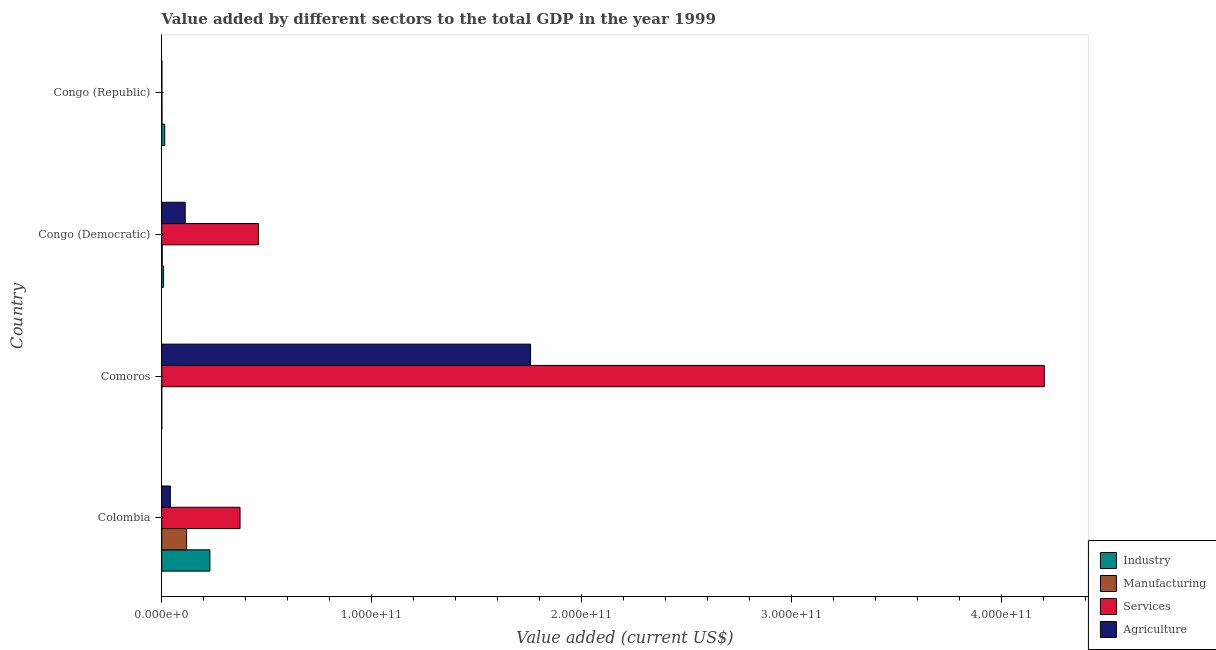How many groups of bars are there?
Offer a terse response. 4. How many bars are there on the 1st tick from the top?
Your answer should be very brief. 4. What is the label of the 1st group of bars from the top?
Your answer should be very brief. Congo (Republic). In how many cases, is the number of bars for a given country not equal to the number of legend labels?
Keep it short and to the point. 0. What is the value added by manufacturing sector in Congo (Democratic)?
Provide a succinct answer. 2.36e+08. Across all countries, what is the maximum value added by industrial sector?
Make the answer very short. 2.30e+1. Across all countries, what is the minimum value added by services sector?
Give a very brief answer. 1.05e+08. In which country was the value added by agricultural sector maximum?
Your answer should be compact. Comoros. In which country was the value added by services sector minimum?
Your answer should be very brief. Congo (Republic). What is the total value added by agricultural sector in the graph?
Provide a short and direct response. 1.91e+11. What is the difference between the value added by manufacturing sector in Colombia and that in Comoros?
Your answer should be very brief. 1.19e+1. What is the difference between the value added by services sector in Colombia and the value added by agricultural sector in Comoros?
Provide a short and direct response. -1.38e+11. What is the average value added by industrial sector per country?
Provide a succinct answer. 6.33e+09. What is the difference between the value added by services sector and value added by industrial sector in Congo (Democratic)?
Your answer should be compact. 4.52e+1. In how many countries, is the value added by manufacturing sector greater than 140000000000 US$?
Your response must be concise. 0. What is the ratio of the value added by services sector in Comoros to that in Congo (Republic)?
Your response must be concise. 4010.61. Is the difference between the value added by manufacturing sector in Colombia and Congo (Democratic) greater than the difference between the value added by agricultural sector in Colombia and Congo (Democratic)?
Provide a succinct answer. Yes. What is the difference between the highest and the second highest value added by manufacturing sector?
Your answer should be compact. 1.16e+1. What is the difference between the highest and the lowest value added by industrial sector?
Make the answer very short. 2.29e+1. Is the sum of the value added by services sector in Comoros and Congo (Democratic) greater than the maximum value added by industrial sector across all countries?
Your answer should be very brief. Yes. Is it the case that in every country, the sum of the value added by agricultural sector and value added by services sector is greater than the sum of value added by manufacturing sector and value added by industrial sector?
Ensure brevity in your answer.  No. What does the 4th bar from the top in Congo (Democratic) represents?
Your answer should be compact. Industry. What does the 4th bar from the bottom in Comoros represents?
Your answer should be very brief. Agriculture. What is the difference between two consecutive major ticks on the X-axis?
Offer a terse response. 1.00e+11. Are the values on the major ticks of X-axis written in scientific E-notation?
Offer a very short reply. Yes. Does the graph contain any zero values?
Your response must be concise. No. Does the graph contain grids?
Keep it short and to the point. No. Where does the legend appear in the graph?
Provide a short and direct response. Bottom right. How are the legend labels stacked?
Give a very brief answer. Vertical. What is the title of the graph?
Your answer should be very brief. Value added by different sectors to the total GDP in the year 1999. What is the label or title of the X-axis?
Give a very brief answer. Value added (current US$). What is the Value added (current US$) of Industry in Colombia?
Your answer should be very brief. 2.30e+1. What is the Value added (current US$) of Manufacturing in Colombia?
Offer a very short reply. 1.19e+1. What is the Value added (current US$) in Services in Colombia?
Give a very brief answer. 3.73e+1. What is the Value added (current US$) of Agriculture in Colombia?
Keep it short and to the point. 4.10e+09. What is the Value added (current US$) in Industry in Comoros?
Your response must be concise. 2.66e+07. What is the Value added (current US$) of Manufacturing in Comoros?
Provide a succinct answer. 9.27e+06. What is the Value added (current US$) of Services in Comoros?
Your response must be concise. 4.21e+11. What is the Value added (current US$) of Agriculture in Comoros?
Your answer should be very brief. 1.76e+11. What is the Value added (current US$) in Industry in Congo (Democratic)?
Your answer should be very brief. 8.82e+08. What is the Value added (current US$) in Manufacturing in Congo (Democratic)?
Your response must be concise. 2.36e+08. What is the Value added (current US$) of Services in Congo (Democratic)?
Your answer should be very brief. 4.61e+1. What is the Value added (current US$) of Agriculture in Congo (Democratic)?
Offer a terse response. 1.12e+1. What is the Value added (current US$) of Industry in Congo (Republic)?
Make the answer very short. 1.44e+09. What is the Value added (current US$) in Manufacturing in Congo (Republic)?
Keep it short and to the point. 1.29e+08. What is the Value added (current US$) of Services in Congo (Republic)?
Provide a short and direct response. 1.05e+08. What is the Value added (current US$) of Agriculture in Congo (Republic)?
Make the answer very short. 9.11e+07. Across all countries, what is the maximum Value added (current US$) of Industry?
Offer a terse response. 2.30e+1. Across all countries, what is the maximum Value added (current US$) of Manufacturing?
Provide a succinct answer. 1.19e+1. Across all countries, what is the maximum Value added (current US$) in Services?
Offer a very short reply. 4.21e+11. Across all countries, what is the maximum Value added (current US$) in Agriculture?
Provide a short and direct response. 1.76e+11. Across all countries, what is the minimum Value added (current US$) of Industry?
Your response must be concise. 2.66e+07. Across all countries, what is the minimum Value added (current US$) in Manufacturing?
Give a very brief answer. 9.27e+06. Across all countries, what is the minimum Value added (current US$) of Services?
Offer a terse response. 1.05e+08. Across all countries, what is the minimum Value added (current US$) in Agriculture?
Make the answer very short. 9.11e+07. What is the total Value added (current US$) of Industry in the graph?
Keep it short and to the point. 2.53e+1. What is the total Value added (current US$) of Manufacturing in the graph?
Offer a terse response. 1.22e+1. What is the total Value added (current US$) in Services in the graph?
Provide a short and direct response. 5.04e+11. What is the total Value added (current US$) in Agriculture in the graph?
Give a very brief answer. 1.91e+11. What is the difference between the Value added (current US$) of Industry in Colombia and that in Comoros?
Your answer should be compact. 2.29e+1. What is the difference between the Value added (current US$) in Manufacturing in Colombia and that in Comoros?
Provide a succinct answer. 1.19e+1. What is the difference between the Value added (current US$) in Services in Colombia and that in Comoros?
Your answer should be very brief. -3.83e+11. What is the difference between the Value added (current US$) of Agriculture in Colombia and that in Comoros?
Your answer should be very brief. -1.72e+11. What is the difference between the Value added (current US$) in Industry in Colombia and that in Congo (Democratic)?
Your response must be concise. 2.21e+1. What is the difference between the Value added (current US$) in Manufacturing in Colombia and that in Congo (Democratic)?
Provide a succinct answer. 1.16e+1. What is the difference between the Value added (current US$) of Services in Colombia and that in Congo (Democratic)?
Provide a short and direct response. -8.77e+09. What is the difference between the Value added (current US$) of Agriculture in Colombia and that in Congo (Democratic)?
Offer a very short reply. -7.10e+09. What is the difference between the Value added (current US$) in Industry in Colombia and that in Congo (Republic)?
Keep it short and to the point. 2.15e+1. What is the difference between the Value added (current US$) of Manufacturing in Colombia and that in Congo (Republic)?
Your answer should be compact. 1.17e+1. What is the difference between the Value added (current US$) in Services in Colombia and that in Congo (Republic)?
Provide a short and direct response. 3.72e+1. What is the difference between the Value added (current US$) in Agriculture in Colombia and that in Congo (Republic)?
Provide a short and direct response. 4.01e+09. What is the difference between the Value added (current US$) of Industry in Comoros and that in Congo (Democratic)?
Offer a terse response. -8.55e+08. What is the difference between the Value added (current US$) in Manufacturing in Comoros and that in Congo (Democratic)?
Your answer should be compact. -2.27e+08. What is the difference between the Value added (current US$) in Services in Comoros and that in Congo (Democratic)?
Offer a very short reply. 3.74e+11. What is the difference between the Value added (current US$) of Agriculture in Comoros and that in Congo (Democratic)?
Your answer should be compact. 1.65e+11. What is the difference between the Value added (current US$) of Industry in Comoros and that in Congo (Republic)?
Your answer should be very brief. -1.42e+09. What is the difference between the Value added (current US$) in Manufacturing in Comoros and that in Congo (Republic)?
Give a very brief answer. -1.19e+08. What is the difference between the Value added (current US$) in Services in Comoros and that in Congo (Republic)?
Your response must be concise. 4.20e+11. What is the difference between the Value added (current US$) of Agriculture in Comoros and that in Congo (Republic)?
Your response must be concise. 1.76e+11. What is the difference between the Value added (current US$) of Industry in Congo (Democratic) and that in Congo (Republic)?
Make the answer very short. -5.61e+08. What is the difference between the Value added (current US$) of Manufacturing in Congo (Democratic) and that in Congo (Republic)?
Provide a short and direct response. 1.08e+08. What is the difference between the Value added (current US$) in Services in Congo (Democratic) and that in Congo (Republic)?
Offer a terse response. 4.60e+1. What is the difference between the Value added (current US$) in Agriculture in Congo (Democratic) and that in Congo (Republic)?
Your response must be concise. 1.11e+1. What is the difference between the Value added (current US$) in Industry in Colombia and the Value added (current US$) in Manufacturing in Comoros?
Your response must be concise. 2.29e+1. What is the difference between the Value added (current US$) in Industry in Colombia and the Value added (current US$) in Services in Comoros?
Ensure brevity in your answer.  -3.98e+11. What is the difference between the Value added (current US$) of Industry in Colombia and the Value added (current US$) of Agriculture in Comoros?
Keep it short and to the point. -1.53e+11. What is the difference between the Value added (current US$) of Manufacturing in Colombia and the Value added (current US$) of Services in Comoros?
Offer a terse response. -4.09e+11. What is the difference between the Value added (current US$) of Manufacturing in Colombia and the Value added (current US$) of Agriculture in Comoros?
Make the answer very short. -1.64e+11. What is the difference between the Value added (current US$) of Services in Colombia and the Value added (current US$) of Agriculture in Comoros?
Your response must be concise. -1.38e+11. What is the difference between the Value added (current US$) in Industry in Colombia and the Value added (current US$) in Manufacturing in Congo (Democratic)?
Provide a succinct answer. 2.27e+1. What is the difference between the Value added (current US$) of Industry in Colombia and the Value added (current US$) of Services in Congo (Democratic)?
Ensure brevity in your answer.  -2.31e+1. What is the difference between the Value added (current US$) in Industry in Colombia and the Value added (current US$) in Agriculture in Congo (Democratic)?
Provide a short and direct response. 1.17e+1. What is the difference between the Value added (current US$) in Manufacturing in Colombia and the Value added (current US$) in Services in Congo (Democratic)?
Make the answer very short. -3.42e+1. What is the difference between the Value added (current US$) in Manufacturing in Colombia and the Value added (current US$) in Agriculture in Congo (Democratic)?
Give a very brief answer. 6.56e+08. What is the difference between the Value added (current US$) in Services in Colombia and the Value added (current US$) in Agriculture in Congo (Democratic)?
Give a very brief answer. 2.61e+1. What is the difference between the Value added (current US$) in Industry in Colombia and the Value added (current US$) in Manufacturing in Congo (Republic)?
Your response must be concise. 2.28e+1. What is the difference between the Value added (current US$) of Industry in Colombia and the Value added (current US$) of Services in Congo (Republic)?
Provide a short and direct response. 2.28e+1. What is the difference between the Value added (current US$) of Industry in Colombia and the Value added (current US$) of Agriculture in Congo (Republic)?
Ensure brevity in your answer.  2.29e+1. What is the difference between the Value added (current US$) in Manufacturing in Colombia and the Value added (current US$) in Services in Congo (Republic)?
Make the answer very short. 1.18e+1. What is the difference between the Value added (current US$) of Manufacturing in Colombia and the Value added (current US$) of Agriculture in Congo (Republic)?
Give a very brief answer. 1.18e+1. What is the difference between the Value added (current US$) of Services in Colombia and the Value added (current US$) of Agriculture in Congo (Republic)?
Provide a short and direct response. 3.72e+1. What is the difference between the Value added (current US$) of Industry in Comoros and the Value added (current US$) of Manufacturing in Congo (Democratic)?
Your answer should be very brief. -2.10e+08. What is the difference between the Value added (current US$) in Industry in Comoros and the Value added (current US$) in Services in Congo (Democratic)?
Your response must be concise. -4.61e+1. What is the difference between the Value added (current US$) of Industry in Comoros and the Value added (current US$) of Agriculture in Congo (Democratic)?
Offer a terse response. -1.12e+1. What is the difference between the Value added (current US$) of Manufacturing in Comoros and the Value added (current US$) of Services in Congo (Democratic)?
Offer a very short reply. -4.61e+1. What is the difference between the Value added (current US$) in Manufacturing in Comoros and the Value added (current US$) in Agriculture in Congo (Democratic)?
Offer a very short reply. -1.12e+1. What is the difference between the Value added (current US$) of Services in Comoros and the Value added (current US$) of Agriculture in Congo (Democratic)?
Your answer should be compact. 4.09e+11. What is the difference between the Value added (current US$) in Industry in Comoros and the Value added (current US$) in Manufacturing in Congo (Republic)?
Keep it short and to the point. -1.02e+08. What is the difference between the Value added (current US$) in Industry in Comoros and the Value added (current US$) in Services in Congo (Republic)?
Give a very brief answer. -7.83e+07. What is the difference between the Value added (current US$) of Industry in Comoros and the Value added (current US$) of Agriculture in Congo (Republic)?
Make the answer very short. -6.46e+07. What is the difference between the Value added (current US$) of Manufacturing in Comoros and the Value added (current US$) of Services in Congo (Republic)?
Make the answer very short. -9.56e+07. What is the difference between the Value added (current US$) in Manufacturing in Comoros and the Value added (current US$) in Agriculture in Congo (Republic)?
Your answer should be very brief. -8.19e+07. What is the difference between the Value added (current US$) in Services in Comoros and the Value added (current US$) in Agriculture in Congo (Republic)?
Your answer should be compact. 4.20e+11. What is the difference between the Value added (current US$) in Industry in Congo (Democratic) and the Value added (current US$) in Manufacturing in Congo (Republic)?
Provide a short and direct response. 7.53e+08. What is the difference between the Value added (current US$) of Industry in Congo (Democratic) and the Value added (current US$) of Services in Congo (Republic)?
Ensure brevity in your answer.  7.77e+08. What is the difference between the Value added (current US$) of Industry in Congo (Democratic) and the Value added (current US$) of Agriculture in Congo (Republic)?
Provide a succinct answer. 7.91e+08. What is the difference between the Value added (current US$) of Manufacturing in Congo (Democratic) and the Value added (current US$) of Services in Congo (Republic)?
Provide a short and direct response. 1.31e+08. What is the difference between the Value added (current US$) of Manufacturing in Congo (Democratic) and the Value added (current US$) of Agriculture in Congo (Republic)?
Your response must be concise. 1.45e+08. What is the difference between the Value added (current US$) of Services in Congo (Democratic) and the Value added (current US$) of Agriculture in Congo (Republic)?
Provide a succinct answer. 4.60e+1. What is the average Value added (current US$) in Industry per country?
Ensure brevity in your answer.  6.33e+09. What is the average Value added (current US$) in Manufacturing per country?
Offer a terse response. 3.06e+09. What is the average Value added (current US$) of Services per country?
Your answer should be compact. 1.26e+11. What is the average Value added (current US$) of Agriculture per country?
Ensure brevity in your answer.  4.78e+1. What is the difference between the Value added (current US$) of Industry and Value added (current US$) of Manufacturing in Colombia?
Provide a succinct answer. 1.11e+1. What is the difference between the Value added (current US$) of Industry and Value added (current US$) of Services in Colombia?
Provide a short and direct response. -1.44e+1. What is the difference between the Value added (current US$) in Industry and Value added (current US$) in Agriculture in Colombia?
Ensure brevity in your answer.  1.89e+1. What is the difference between the Value added (current US$) of Manufacturing and Value added (current US$) of Services in Colombia?
Offer a terse response. -2.55e+1. What is the difference between the Value added (current US$) of Manufacturing and Value added (current US$) of Agriculture in Colombia?
Give a very brief answer. 7.76e+09. What is the difference between the Value added (current US$) in Services and Value added (current US$) in Agriculture in Colombia?
Your answer should be very brief. 3.32e+1. What is the difference between the Value added (current US$) of Industry and Value added (current US$) of Manufacturing in Comoros?
Your response must be concise. 1.73e+07. What is the difference between the Value added (current US$) of Industry and Value added (current US$) of Services in Comoros?
Offer a terse response. -4.20e+11. What is the difference between the Value added (current US$) in Industry and Value added (current US$) in Agriculture in Comoros?
Your response must be concise. -1.76e+11. What is the difference between the Value added (current US$) of Manufacturing and Value added (current US$) of Services in Comoros?
Offer a terse response. -4.21e+11. What is the difference between the Value added (current US$) of Manufacturing and Value added (current US$) of Agriculture in Comoros?
Ensure brevity in your answer.  -1.76e+11. What is the difference between the Value added (current US$) of Services and Value added (current US$) of Agriculture in Comoros?
Offer a terse response. 2.45e+11. What is the difference between the Value added (current US$) in Industry and Value added (current US$) in Manufacturing in Congo (Democratic)?
Keep it short and to the point. 6.45e+08. What is the difference between the Value added (current US$) of Industry and Value added (current US$) of Services in Congo (Democratic)?
Give a very brief answer. -4.52e+1. What is the difference between the Value added (current US$) of Industry and Value added (current US$) of Agriculture in Congo (Democratic)?
Your response must be concise. -1.03e+1. What is the difference between the Value added (current US$) of Manufacturing and Value added (current US$) of Services in Congo (Democratic)?
Provide a short and direct response. -4.59e+1. What is the difference between the Value added (current US$) of Manufacturing and Value added (current US$) of Agriculture in Congo (Democratic)?
Make the answer very short. -1.10e+1. What is the difference between the Value added (current US$) in Services and Value added (current US$) in Agriculture in Congo (Democratic)?
Your answer should be very brief. 3.49e+1. What is the difference between the Value added (current US$) in Industry and Value added (current US$) in Manufacturing in Congo (Republic)?
Make the answer very short. 1.31e+09. What is the difference between the Value added (current US$) in Industry and Value added (current US$) in Services in Congo (Republic)?
Offer a very short reply. 1.34e+09. What is the difference between the Value added (current US$) of Industry and Value added (current US$) of Agriculture in Congo (Republic)?
Offer a very short reply. 1.35e+09. What is the difference between the Value added (current US$) in Manufacturing and Value added (current US$) in Services in Congo (Republic)?
Keep it short and to the point. 2.38e+07. What is the difference between the Value added (current US$) in Manufacturing and Value added (current US$) in Agriculture in Congo (Republic)?
Your answer should be very brief. 3.75e+07. What is the difference between the Value added (current US$) of Services and Value added (current US$) of Agriculture in Congo (Republic)?
Give a very brief answer. 1.37e+07. What is the ratio of the Value added (current US$) of Industry in Colombia to that in Comoros?
Keep it short and to the point. 863.53. What is the ratio of the Value added (current US$) in Manufacturing in Colombia to that in Comoros?
Make the answer very short. 1280.01. What is the ratio of the Value added (current US$) of Services in Colombia to that in Comoros?
Your response must be concise. 0.09. What is the ratio of the Value added (current US$) of Agriculture in Colombia to that in Comoros?
Give a very brief answer. 0.02. What is the ratio of the Value added (current US$) in Industry in Colombia to that in Congo (Democratic)?
Make the answer very short. 26.03. What is the ratio of the Value added (current US$) in Manufacturing in Colombia to that in Congo (Democratic)?
Your response must be concise. 50.21. What is the ratio of the Value added (current US$) in Services in Colombia to that in Congo (Democratic)?
Offer a very short reply. 0.81. What is the ratio of the Value added (current US$) in Agriculture in Colombia to that in Congo (Democratic)?
Provide a succinct answer. 0.37. What is the ratio of the Value added (current US$) in Industry in Colombia to that in Congo (Republic)?
Ensure brevity in your answer.  15.92. What is the ratio of the Value added (current US$) in Manufacturing in Colombia to that in Congo (Republic)?
Keep it short and to the point. 92.21. What is the ratio of the Value added (current US$) in Services in Colombia to that in Congo (Republic)?
Offer a very short reply. 356.01. What is the ratio of the Value added (current US$) of Agriculture in Colombia to that in Congo (Republic)?
Provide a short and direct response. 45.03. What is the ratio of the Value added (current US$) of Industry in Comoros to that in Congo (Democratic)?
Make the answer very short. 0.03. What is the ratio of the Value added (current US$) in Manufacturing in Comoros to that in Congo (Democratic)?
Offer a terse response. 0.04. What is the ratio of the Value added (current US$) in Services in Comoros to that in Congo (Democratic)?
Offer a terse response. 9.12. What is the ratio of the Value added (current US$) in Agriculture in Comoros to that in Congo (Democratic)?
Give a very brief answer. 15.68. What is the ratio of the Value added (current US$) in Industry in Comoros to that in Congo (Republic)?
Make the answer very short. 0.02. What is the ratio of the Value added (current US$) of Manufacturing in Comoros to that in Congo (Republic)?
Your answer should be compact. 0.07. What is the ratio of the Value added (current US$) in Services in Comoros to that in Congo (Republic)?
Keep it short and to the point. 4010.62. What is the ratio of the Value added (current US$) of Agriculture in Comoros to that in Congo (Republic)?
Offer a very short reply. 1928.09. What is the ratio of the Value added (current US$) in Industry in Congo (Democratic) to that in Congo (Republic)?
Your response must be concise. 0.61. What is the ratio of the Value added (current US$) in Manufacturing in Congo (Democratic) to that in Congo (Republic)?
Keep it short and to the point. 1.84. What is the ratio of the Value added (current US$) in Services in Congo (Democratic) to that in Congo (Republic)?
Offer a very short reply. 439.67. What is the ratio of the Value added (current US$) of Agriculture in Congo (Democratic) to that in Congo (Republic)?
Your answer should be very brief. 122.93. What is the difference between the highest and the second highest Value added (current US$) in Industry?
Offer a very short reply. 2.15e+1. What is the difference between the highest and the second highest Value added (current US$) of Manufacturing?
Offer a terse response. 1.16e+1. What is the difference between the highest and the second highest Value added (current US$) of Services?
Your answer should be compact. 3.74e+11. What is the difference between the highest and the second highest Value added (current US$) in Agriculture?
Offer a terse response. 1.65e+11. What is the difference between the highest and the lowest Value added (current US$) of Industry?
Make the answer very short. 2.29e+1. What is the difference between the highest and the lowest Value added (current US$) of Manufacturing?
Keep it short and to the point. 1.19e+1. What is the difference between the highest and the lowest Value added (current US$) in Services?
Provide a succinct answer. 4.20e+11. What is the difference between the highest and the lowest Value added (current US$) of Agriculture?
Offer a very short reply. 1.76e+11. 